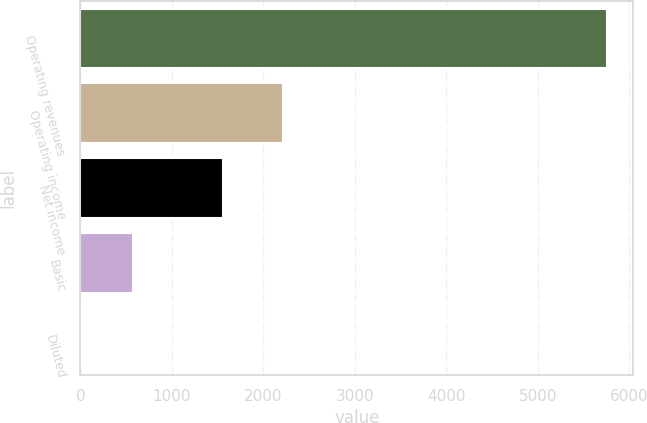Convert chart. <chart><loc_0><loc_0><loc_500><loc_500><bar_chart><fcel>Operating revenues<fcel>Operating income<fcel>Net income<fcel>Basic<fcel>Diluted<nl><fcel>5757<fcel>2210<fcel>1554<fcel>577.61<fcel>2.12<nl></chart> 